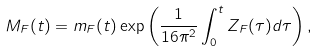Convert formula to latex. <formula><loc_0><loc_0><loc_500><loc_500>M _ { F } ( t ) = m _ { F } ( t ) \exp \left ( \frac { 1 } { 1 6 \pi ^ { 2 } } \int _ { 0 } ^ { t } Z _ { F } ( \tau ) d \tau \right ) ,</formula> 